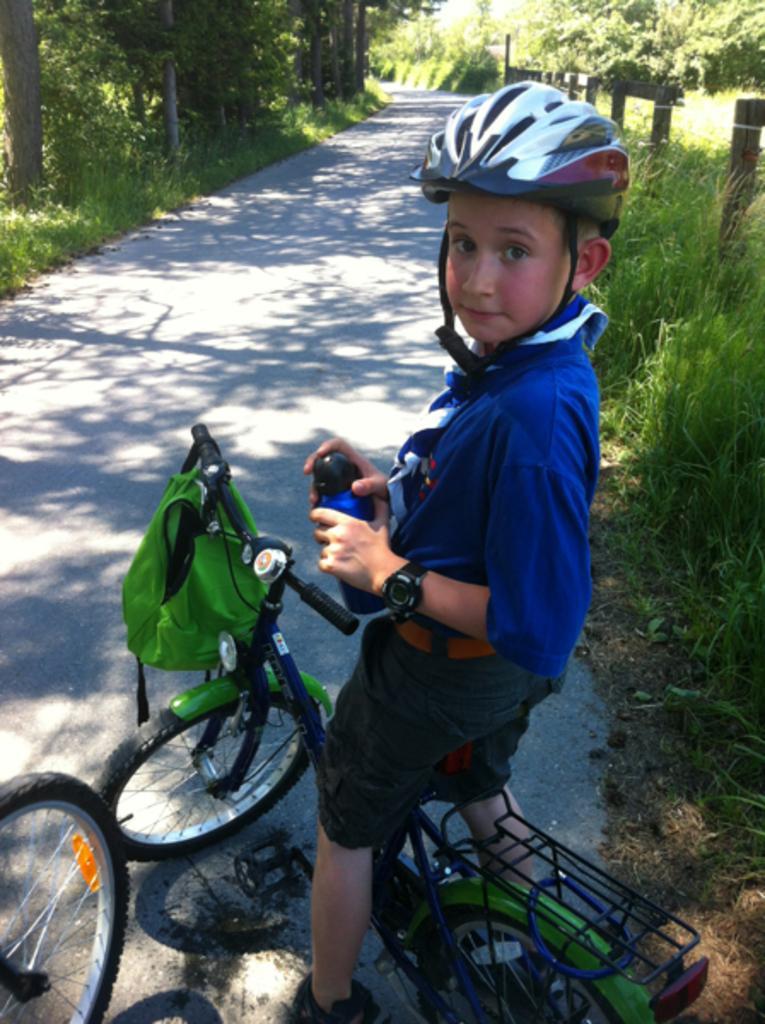Describe this image in one or two sentences. In the middle of the image a boy is standing on a bicycle and holding a bottle in his hand. Top right side of the image there is grass and fencing and there are some trees. Bottom left side of the image there is a wheel on the road. 